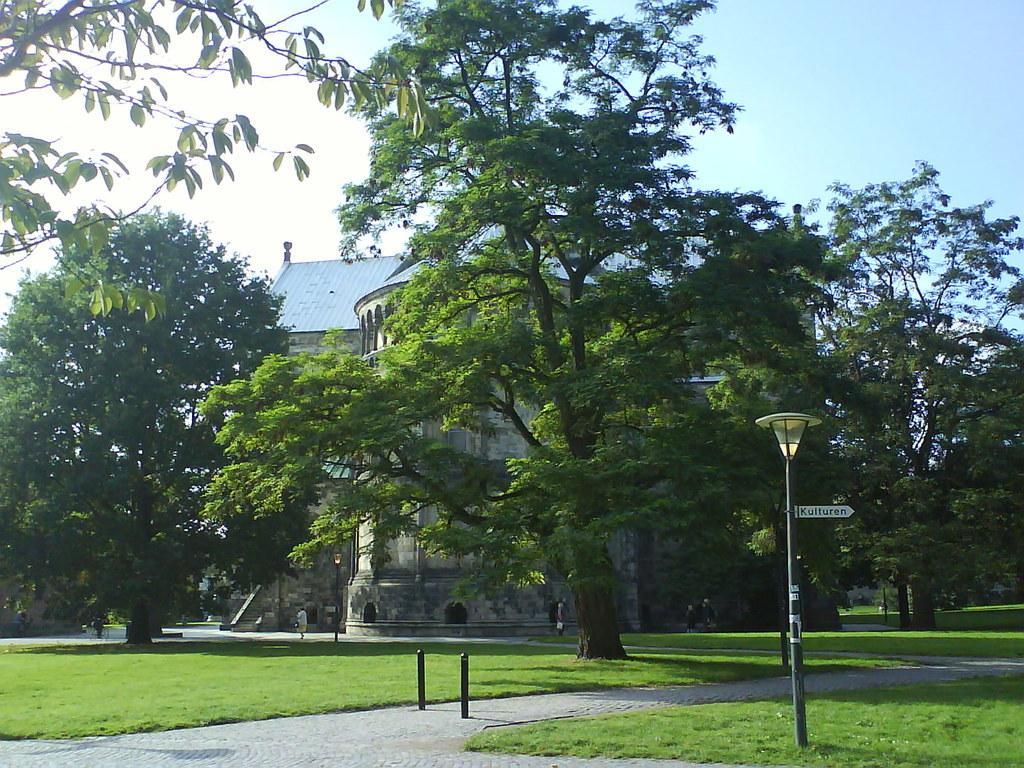In one or two sentences, can you explain what this image depicts? In this image we can see building, street lights, street poles, sign board, barriers, ground, trees and sky. 